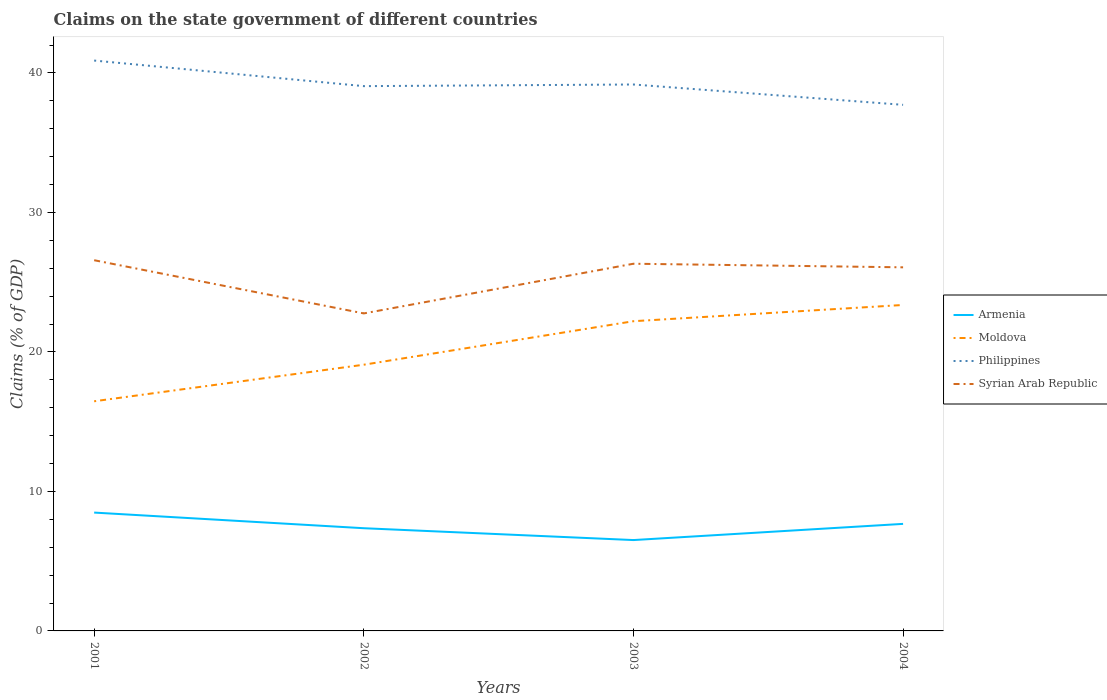Is the number of lines equal to the number of legend labels?
Your answer should be compact. Yes. Across all years, what is the maximum percentage of GDP claimed on the state government in Moldova?
Your response must be concise. 16.46. In which year was the percentage of GDP claimed on the state government in Moldova maximum?
Ensure brevity in your answer.  2001. What is the total percentage of GDP claimed on the state government in Armenia in the graph?
Offer a very short reply. 1.12. What is the difference between the highest and the second highest percentage of GDP claimed on the state government in Philippines?
Your response must be concise. 3.17. What is the difference between the highest and the lowest percentage of GDP claimed on the state government in Syrian Arab Republic?
Ensure brevity in your answer.  3. Is the percentage of GDP claimed on the state government in Armenia strictly greater than the percentage of GDP claimed on the state government in Moldova over the years?
Offer a very short reply. Yes. How many lines are there?
Keep it short and to the point. 4. How many years are there in the graph?
Give a very brief answer. 4. Does the graph contain grids?
Your answer should be compact. No. Where does the legend appear in the graph?
Provide a succinct answer. Center right. How many legend labels are there?
Your answer should be compact. 4. What is the title of the graph?
Provide a short and direct response. Claims on the state government of different countries. What is the label or title of the Y-axis?
Provide a succinct answer. Claims (% of GDP). What is the Claims (% of GDP) of Armenia in 2001?
Keep it short and to the point. 8.48. What is the Claims (% of GDP) in Moldova in 2001?
Provide a short and direct response. 16.46. What is the Claims (% of GDP) in Philippines in 2001?
Give a very brief answer. 40.89. What is the Claims (% of GDP) of Syrian Arab Republic in 2001?
Give a very brief answer. 26.57. What is the Claims (% of GDP) in Armenia in 2002?
Offer a very short reply. 7.36. What is the Claims (% of GDP) of Moldova in 2002?
Offer a very short reply. 19.08. What is the Claims (% of GDP) in Philippines in 2002?
Your answer should be very brief. 39.05. What is the Claims (% of GDP) in Syrian Arab Republic in 2002?
Your answer should be compact. 22.76. What is the Claims (% of GDP) of Armenia in 2003?
Keep it short and to the point. 6.51. What is the Claims (% of GDP) in Moldova in 2003?
Offer a very short reply. 22.2. What is the Claims (% of GDP) of Philippines in 2003?
Keep it short and to the point. 39.17. What is the Claims (% of GDP) of Syrian Arab Republic in 2003?
Provide a short and direct response. 26.32. What is the Claims (% of GDP) in Armenia in 2004?
Your answer should be very brief. 7.67. What is the Claims (% of GDP) in Moldova in 2004?
Ensure brevity in your answer.  23.37. What is the Claims (% of GDP) in Philippines in 2004?
Provide a short and direct response. 37.71. What is the Claims (% of GDP) in Syrian Arab Republic in 2004?
Keep it short and to the point. 26.06. Across all years, what is the maximum Claims (% of GDP) of Armenia?
Offer a very short reply. 8.48. Across all years, what is the maximum Claims (% of GDP) of Moldova?
Offer a very short reply. 23.37. Across all years, what is the maximum Claims (% of GDP) of Philippines?
Offer a terse response. 40.89. Across all years, what is the maximum Claims (% of GDP) of Syrian Arab Republic?
Keep it short and to the point. 26.57. Across all years, what is the minimum Claims (% of GDP) of Armenia?
Your answer should be compact. 6.51. Across all years, what is the minimum Claims (% of GDP) of Moldova?
Offer a very short reply. 16.46. Across all years, what is the minimum Claims (% of GDP) of Philippines?
Give a very brief answer. 37.71. Across all years, what is the minimum Claims (% of GDP) in Syrian Arab Republic?
Make the answer very short. 22.76. What is the total Claims (% of GDP) in Armenia in the graph?
Provide a succinct answer. 30.03. What is the total Claims (% of GDP) in Moldova in the graph?
Offer a terse response. 81.11. What is the total Claims (% of GDP) in Philippines in the graph?
Provide a short and direct response. 156.82. What is the total Claims (% of GDP) of Syrian Arab Republic in the graph?
Provide a short and direct response. 101.72. What is the difference between the Claims (% of GDP) of Armenia in 2001 and that in 2002?
Provide a short and direct response. 1.12. What is the difference between the Claims (% of GDP) in Moldova in 2001 and that in 2002?
Your answer should be very brief. -2.62. What is the difference between the Claims (% of GDP) in Philippines in 2001 and that in 2002?
Give a very brief answer. 1.83. What is the difference between the Claims (% of GDP) in Syrian Arab Republic in 2001 and that in 2002?
Provide a succinct answer. 3.81. What is the difference between the Claims (% of GDP) in Armenia in 2001 and that in 2003?
Provide a short and direct response. 1.97. What is the difference between the Claims (% of GDP) in Moldova in 2001 and that in 2003?
Your answer should be compact. -5.74. What is the difference between the Claims (% of GDP) of Philippines in 2001 and that in 2003?
Offer a very short reply. 1.72. What is the difference between the Claims (% of GDP) of Syrian Arab Republic in 2001 and that in 2003?
Offer a terse response. 0.25. What is the difference between the Claims (% of GDP) in Armenia in 2001 and that in 2004?
Make the answer very short. 0.81. What is the difference between the Claims (% of GDP) in Moldova in 2001 and that in 2004?
Provide a succinct answer. -6.9. What is the difference between the Claims (% of GDP) of Philippines in 2001 and that in 2004?
Your answer should be compact. 3.17. What is the difference between the Claims (% of GDP) in Syrian Arab Republic in 2001 and that in 2004?
Offer a terse response. 0.51. What is the difference between the Claims (% of GDP) of Armenia in 2002 and that in 2003?
Offer a very short reply. 0.85. What is the difference between the Claims (% of GDP) in Moldova in 2002 and that in 2003?
Your answer should be compact. -3.12. What is the difference between the Claims (% of GDP) in Philippines in 2002 and that in 2003?
Ensure brevity in your answer.  -0.12. What is the difference between the Claims (% of GDP) of Syrian Arab Republic in 2002 and that in 2003?
Give a very brief answer. -3.56. What is the difference between the Claims (% of GDP) in Armenia in 2002 and that in 2004?
Provide a succinct answer. -0.31. What is the difference between the Claims (% of GDP) of Moldova in 2002 and that in 2004?
Make the answer very short. -4.28. What is the difference between the Claims (% of GDP) of Philippines in 2002 and that in 2004?
Give a very brief answer. 1.34. What is the difference between the Claims (% of GDP) in Syrian Arab Republic in 2002 and that in 2004?
Give a very brief answer. -3.3. What is the difference between the Claims (% of GDP) of Armenia in 2003 and that in 2004?
Make the answer very short. -1.16. What is the difference between the Claims (% of GDP) in Moldova in 2003 and that in 2004?
Your answer should be very brief. -1.16. What is the difference between the Claims (% of GDP) in Philippines in 2003 and that in 2004?
Your answer should be compact. 1.46. What is the difference between the Claims (% of GDP) of Syrian Arab Republic in 2003 and that in 2004?
Provide a short and direct response. 0.26. What is the difference between the Claims (% of GDP) in Armenia in 2001 and the Claims (% of GDP) in Moldova in 2002?
Offer a terse response. -10.6. What is the difference between the Claims (% of GDP) in Armenia in 2001 and the Claims (% of GDP) in Philippines in 2002?
Make the answer very short. -30.57. What is the difference between the Claims (% of GDP) in Armenia in 2001 and the Claims (% of GDP) in Syrian Arab Republic in 2002?
Your answer should be very brief. -14.28. What is the difference between the Claims (% of GDP) of Moldova in 2001 and the Claims (% of GDP) of Philippines in 2002?
Provide a succinct answer. -22.59. What is the difference between the Claims (% of GDP) in Moldova in 2001 and the Claims (% of GDP) in Syrian Arab Republic in 2002?
Your response must be concise. -6.3. What is the difference between the Claims (% of GDP) in Philippines in 2001 and the Claims (% of GDP) in Syrian Arab Republic in 2002?
Your response must be concise. 18.13. What is the difference between the Claims (% of GDP) of Armenia in 2001 and the Claims (% of GDP) of Moldova in 2003?
Provide a succinct answer. -13.72. What is the difference between the Claims (% of GDP) in Armenia in 2001 and the Claims (% of GDP) in Philippines in 2003?
Provide a short and direct response. -30.69. What is the difference between the Claims (% of GDP) in Armenia in 2001 and the Claims (% of GDP) in Syrian Arab Republic in 2003?
Provide a short and direct response. -17.84. What is the difference between the Claims (% of GDP) in Moldova in 2001 and the Claims (% of GDP) in Philippines in 2003?
Ensure brevity in your answer.  -22.71. What is the difference between the Claims (% of GDP) of Moldova in 2001 and the Claims (% of GDP) of Syrian Arab Republic in 2003?
Your answer should be compact. -9.86. What is the difference between the Claims (% of GDP) of Philippines in 2001 and the Claims (% of GDP) of Syrian Arab Republic in 2003?
Your response must be concise. 14.56. What is the difference between the Claims (% of GDP) in Armenia in 2001 and the Claims (% of GDP) in Moldova in 2004?
Ensure brevity in your answer.  -14.88. What is the difference between the Claims (% of GDP) in Armenia in 2001 and the Claims (% of GDP) in Philippines in 2004?
Your answer should be compact. -29.23. What is the difference between the Claims (% of GDP) of Armenia in 2001 and the Claims (% of GDP) of Syrian Arab Republic in 2004?
Offer a very short reply. -17.58. What is the difference between the Claims (% of GDP) of Moldova in 2001 and the Claims (% of GDP) of Philippines in 2004?
Make the answer very short. -21.25. What is the difference between the Claims (% of GDP) of Moldova in 2001 and the Claims (% of GDP) of Syrian Arab Republic in 2004?
Offer a terse response. -9.6. What is the difference between the Claims (% of GDP) in Philippines in 2001 and the Claims (% of GDP) in Syrian Arab Republic in 2004?
Give a very brief answer. 14.82. What is the difference between the Claims (% of GDP) of Armenia in 2002 and the Claims (% of GDP) of Moldova in 2003?
Your answer should be compact. -14.84. What is the difference between the Claims (% of GDP) of Armenia in 2002 and the Claims (% of GDP) of Philippines in 2003?
Your response must be concise. -31.81. What is the difference between the Claims (% of GDP) in Armenia in 2002 and the Claims (% of GDP) in Syrian Arab Republic in 2003?
Your answer should be compact. -18.96. What is the difference between the Claims (% of GDP) in Moldova in 2002 and the Claims (% of GDP) in Philippines in 2003?
Give a very brief answer. -20.09. What is the difference between the Claims (% of GDP) in Moldova in 2002 and the Claims (% of GDP) in Syrian Arab Republic in 2003?
Your answer should be compact. -7.24. What is the difference between the Claims (% of GDP) in Philippines in 2002 and the Claims (% of GDP) in Syrian Arab Republic in 2003?
Offer a very short reply. 12.73. What is the difference between the Claims (% of GDP) of Armenia in 2002 and the Claims (% of GDP) of Moldova in 2004?
Offer a terse response. -16. What is the difference between the Claims (% of GDP) in Armenia in 2002 and the Claims (% of GDP) in Philippines in 2004?
Your answer should be very brief. -30.35. What is the difference between the Claims (% of GDP) in Armenia in 2002 and the Claims (% of GDP) in Syrian Arab Republic in 2004?
Provide a succinct answer. -18.7. What is the difference between the Claims (% of GDP) of Moldova in 2002 and the Claims (% of GDP) of Philippines in 2004?
Your answer should be compact. -18.63. What is the difference between the Claims (% of GDP) of Moldova in 2002 and the Claims (% of GDP) of Syrian Arab Republic in 2004?
Make the answer very short. -6.98. What is the difference between the Claims (% of GDP) of Philippines in 2002 and the Claims (% of GDP) of Syrian Arab Republic in 2004?
Provide a short and direct response. 12.99. What is the difference between the Claims (% of GDP) of Armenia in 2003 and the Claims (% of GDP) of Moldova in 2004?
Offer a terse response. -16.85. What is the difference between the Claims (% of GDP) in Armenia in 2003 and the Claims (% of GDP) in Philippines in 2004?
Offer a terse response. -31.2. What is the difference between the Claims (% of GDP) in Armenia in 2003 and the Claims (% of GDP) in Syrian Arab Republic in 2004?
Make the answer very short. -19.55. What is the difference between the Claims (% of GDP) of Moldova in 2003 and the Claims (% of GDP) of Philippines in 2004?
Give a very brief answer. -15.51. What is the difference between the Claims (% of GDP) in Moldova in 2003 and the Claims (% of GDP) in Syrian Arab Republic in 2004?
Make the answer very short. -3.86. What is the difference between the Claims (% of GDP) in Philippines in 2003 and the Claims (% of GDP) in Syrian Arab Republic in 2004?
Give a very brief answer. 13.11. What is the average Claims (% of GDP) of Armenia per year?
Keep it short and to the point. 7.51. What is the average Claims (% of GDP) of Moldova per year?
Offer a very short reply. 20.28. What is the average Claims (% of GDP) in Philippines per year?
Keep it short and to the point. 39.21. What is the average Claims (% of GDP) in Syrian Arab Republic per year?
Offer a terse response. 25.43. In the year 2001, what is the difference between the Claims (% of GDP) of Armenia and Claims (% of GDP) of Moldova?
Provide a succinct answer. -7.98. In the year 2001, what is the difference between the Claims (% of GDP) of Armenia and Claims (% of GDP) of Philippines?
Ensure brevity in your answer.  -32.4. In the year 2001, what is the difference between the Claims (% of GDP) in Armenia and Claims (% of GDP) in Syrian Arab Republic?
Give a very brief answer. -18.09. In the year 2001, what is the difference between the Claims (% of GDP) of Moldova and Claims (% of GDP) of Philippines?
Offer a very short reply. -24.42. In the year 2001, what is the difference between the Claims (% of GDP) of Moldova and Claims (% of GDP) of Syrian Arab Republic?
Provide a succinct answer. -10.11. In the year 2001, what is the difference between the Claims (% of GDP) of Philippines and Claims (% of GDP) of Syrian Arab Republic?
Your answer should be compact. 14.31. In the year 2002, what is the difference between the Claims (% of GDP) of Armenia and Claims (% of GDP) of Moldova?
Offer a terse response. -11.72. In the year 2002, what is the difference between the Claims (% of GDP) in Armenia and Claims (% of GDP) in Philippines?
Your answer should be compact. -31.69. In the year 2002, what is the difference between the Claims (% of GDP) in Armenia and Claims (% of GDP) in Syrian Arab Republic?
Your answer should be compact. -15.4. In the year 2002, what is the difference between the Claims (% of GDP) of Moldova and Claims (% of GDP) of Philippines?
Provide a short and direct response. -19.97. In the year 2002, what is the difference between the Claims (% of GDP) in Moldova and Claims (% of GDP) in Syrian Arab Republic?
Your response must be concise. -3.68. In the year 2002, what is the difference between the Claims (% of GDP) of Philippines and Claims (% of GDP) of Syrian Arab Republic?
Provide a short and direct response. 16.29. In the year 2003, what is the difference between the Claims (% of GDP) in Armenia and Claims (% of GDP) in Moldova?
Provide a succinct answer. -15.69. In the year 2003, what is the difference between the Claims (% of GDP) in Armenia and Claims (% of GDP) in Philippines?
Give a very brief answer. -32.66. In the year 2003, what is the difference between the Claims (% of GDP) in Armenia and Claims (% of GDP) in Syrian Arab Republic?
Your response must be concise. -19.81. In the year 2003, what is the difference between the Claims (% of GDP) of Moldova and Claims (% of GDP) of Philippines?
Ensure brevity in your answer.  -16.97. In the year 2003, what is the difference between the Claims (% of GDP) of Moldova and Claims (% of GDP) of Syrian Arab Republic?
Your answer should be compact. -4.12. In the year 2003, what is the difference between the Claims (% of GDP) in Philippines and Claims (% of GDP) in Syrian Arab Republic?
Ensure brevity in your answer.  12.85. In the year 2004, what is the difference between the Claims (% of GDP) of Armenia and Claims (% of GDP) of Moldova?
Give a very brief answer. -15.69. In the year 2004, what is the difference between the Claims (% of GDP) in Armenia and Claims (% of GDP) in Philippines?
Keep it short and to the point. -30.04. In the year 2004, what is the difference between the Claims (% of GDP) in Armenia and Claims (% of GDP) in Syrian Arab Republic?
Keep it short and to the point. -18.39. In the year 2004, what is the difference between the Claims (% of GDP) in Moldova and Claims (% of GDP) in Philippines?
Provide a short and direct response. -14.35. In the year 2004, what is the difference between the Claims (% of GDP) of Moldova and Claims (% of GDP) of Syrian Arab Republic?
Keep it short and to the point. -2.7. In the year 2004, what is the difference between the Claims (% of GDP) in Philippines and Claims (% of GDP) in Syrian Arab Republic?
Provide a short and direct response. 11.65. What is the ratio of the Claims (% of GDP) in Armenia in 2001 to that in 2002?
Provide a succinct answer. 1.15. What is the ratio of the Claims (% of GDP) in Moldova in 2001 to that in 2002?
Give a very brief answer. 0.86. What is the ratio of the Claims (% of GDP) in Philippines in 2001 to that in 2002?
Provide a succinct answer. 1.05. What is the ratio of the Claims (% of GDP) of Syrian Arab Republic in 2001 to that in 2002?
Your answer should be very brief. 1.17. What is the ratio of the Claims (% of GDP) of Armenia in 2001 to that in 2003?
Your answer should be very brief. 1.3. What is the ratio of the Claims (% of GDP) of Moldova in 2001 to that in 2003?
Provide a succinct answer. 0.74. What is the ratio of the Claims (% of GDP) in Philippines in 2001 to that in 2003?
Offer a terse response. 1.04. What is the ratio of the Claims (% of GDP) in Syrian Arab Republic in 2001 to that in 2003?
Your answer should be very brief. 1.01. What is the ratio of the Claims (% of GDP) of Armenia in 2001 to that in 2004?
Offer a terse response. 1.11. What is the ratio of the Claims (% of GDP) in Moldova in 2001 to that in 2004?
Ensure brevity in your answer.  0.7. What is the ratio of the Claims (% of GDP) of Philippines in 2001 to that in 2004?
Offer a very short reply. 1.08. What is the ratio of the Claims (% of GDP) in Syrian Arab Republic in 2001 to that in 2004?
Provide a succinct answer. 1.02. What is the ratio of the Claims (% of GDP) of Armenia in 2002 to that in 2003?
Your answer should be compact. 1.13. What is the ratio of the Claims (% of GDP) of Moldova in 2002 to that in 2003?
Your answer should be very brief. 0.86. What is the ratio of the Claims (% of GDP) in Philippines in 2002 to that in 2003?
Provide a short and direct response. 1. What is the ratio of the Claims (% of GDP) in Syrian Arab Republic in 2002 to that in 2003?
Keep it short and to the point. 0.86. What is the ratio of the Claims (% of GDP) in Armenia in 2002 to that in 2004?
Give a very brief answer. 0.96. What is the ratio of the Claims (% of GDP) in Moldova in 2002 to that in 2004?
Keep it short and to the point. 0.82. What is the ratio of the Claims (% of GDP) of Philippines in 2002 to that in 2004?
Make the answer very short. 1.04. What is the ratio of the Claims (% of GDP) in Syrian Arab Republic in 2002 to that in 2004?
Ensure brevity in your answer.  0.87. What is the ratio of the Claims (% of GDP) of Armenia in 2003 to that in 2004?
Offer a terse response. 0.85. What is the ratio of the Claims (% of GDP) of Moldova in 2003 to that in 2004?
Your answer should be very brief. 0.95. What is the ratio of the Claims (% of GDP) of Philippines in 2003 to that in 2004?
Provide a succinct answer. 1.04. What is the ratio of the Claims (% of GDP) in Syrian Arab Republic in 2003 to that in 2004?
Your answer should be very brief. 1.01. What is the difference between the highest and the second highest Claims (% of GDP) in Armenia?
Your answer should be compact. 0.81. What is the difference between the highest and the second highest Claims (% of GDP) in Moldova?
Give a very brief answer. 1.16. What is the difference between the highest and the second highest Claims (% of GDP) in Philippines?
Provide a succinct answer. 1.72. What is the difference between the highest and the second highest Claims (% of GDP) of Syrian Arab Republic?
Provide a short and direct response. 0.25. What is the difference between the highest and the lowest Claims (% of GDP) in Armenia?
Your answer should be very brief. 1.97. What is the difference between the highest and the lowest Claims (% of GDP) of Moldova?
Make the answer very short. 6.9. What is the difference between the highest and the lowest Claims (% of GDP) in Philippines?
Your answer should be compact. 3.17. What is the difference between the highest and the lowest Claims (% of GDP) in Syrian Arab Republic?
Make the answer very short. 3.81. 